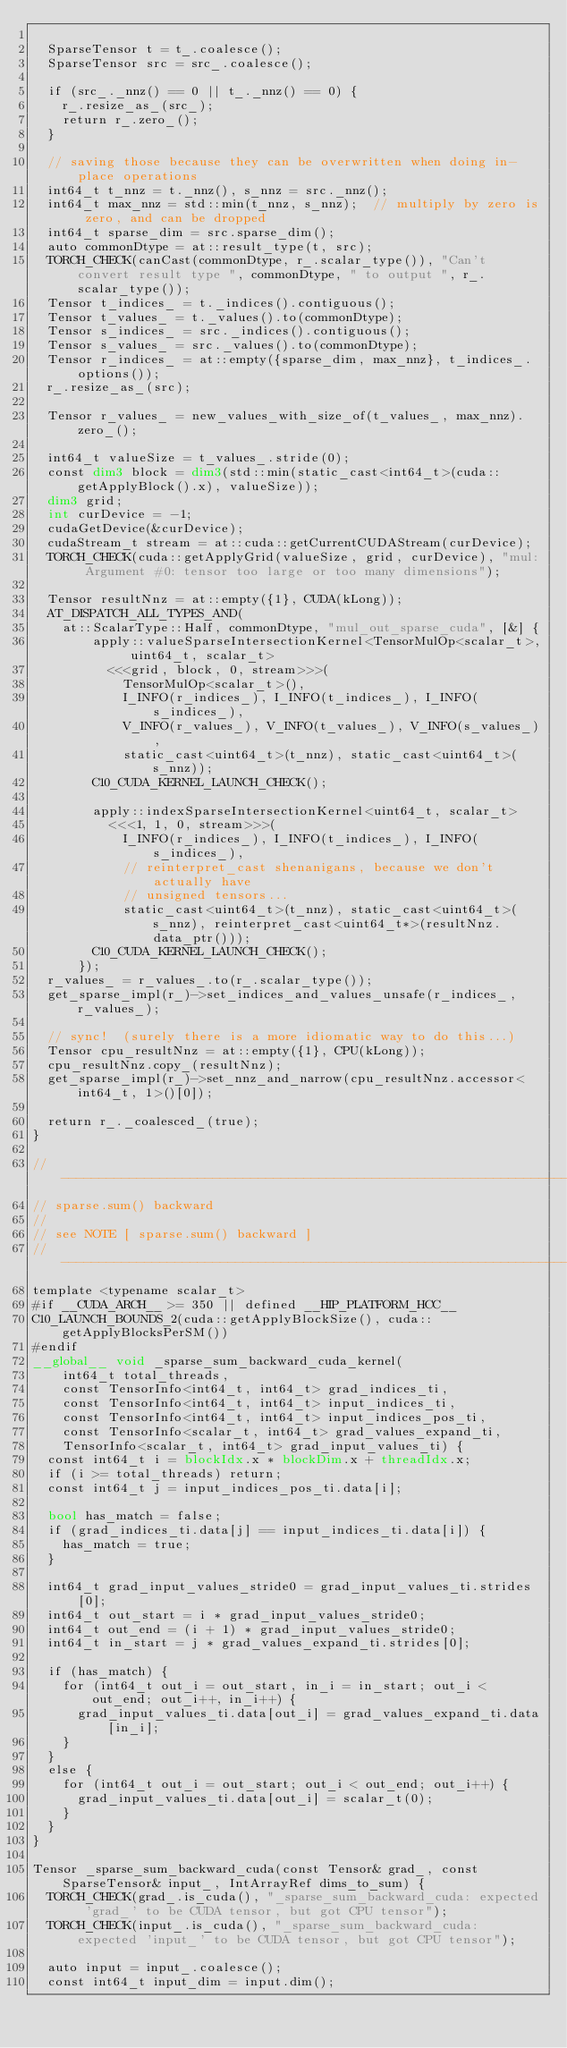Convert code to text. <code><loc_0><loc_0><loc_500><loc_500><_Cuda_>
  SparseTensor t = t_.coalesce();
  SparseTensor src = src_.coalesce();

  if (src_._nnz() == 0 || t_._nnz() == 0) {
    r_.resize_as_(src_);
    return r_.zero_();
  }

  // saving those because they can be overwritten when doing in-place operations
  int64_t t_nnz = t._nnz(), s_nnz = src._nnz();
  int64_t max_nnz = std::min(t_nnz, s_nnz);  // multiply by zero is zero, and can be dropped
  int64_t sparse_dim = src.sparse_dim();
  auto commonDtype = at::result_type(t, src);
  TORCH_CHECK(canCast(commonDtype, r_.scalar_type()), "Can't convert result type ", commonDtype, " to output ", r_.scalar_type());
  Tensor t_indices_ = t._indices().contiguous();
  Tensor t_values_ = t._values().to(commonDtype);
  Tensor s_indices_ = src._indices().contiguous();
  Tensor s_values_ = src._values().to(commonDtype);
  Tensor r_indices_ = at::empty({sparse_dim, max_nnz}, t_indices_.options());
  r_.resize_as_(src);

  Tensor r_values_ = new_values_with_size_of(t_values_, max_nnz).zero_();

  int64_t valueSize = t_values_.stride(0);
  const dim3 block = dim3(std::min(static_cast<int64_t>(cuda::getApplyBlock().x), valueSize));
  dim3 grid;
  int curDevice = -1;
  cudaGetDevice(&curDevice);
  cudaStream_t stream = at::cuda::getCurrentCUDAStream(curDevice);
  TORCH_CHECK(cuda::getApplyGrid(valueSize, grid, curDevice), "mul: Argument #0: tensor too large or too many dimensions");

  Tensor resultNnz = at::empty({1}, CUDA(kLong));
  AT_DISPATCH_ALL_TYPES_AND(
    at::ScalarType::Half, commonDtype, "mul_out_sparse_cuda", [&] {
        apply::valueSparseIntersectionKernel<TensorMulOp<scalar_t>, uint64_t, scalar_t>
          <<<grid, block, 0, stream>>>(
            TensorMulOp<scalar_t>(),
            I_INFO(r_indices_), I_INFO(t_indices_), I_INFO(s_indices_),
            V_INFO(r_values_), V_INFO(t_values_), V_INFO(s_values_),
            static_cast<uint64_t>(t_nnz), static_cast<uint64_t>(s_nnz));
        C10_CUDA_KERNEL_LAUNCH_CHECK();

        apply::indexSparseIntersectionKernel<uint64_t, scalar_t>
          <<<1, 1, 0, stream>>>(
            I_INFO(r_indices_), I_INFO(t_indices_), I_INFO(s_indices_),
            // reinterpret_cast shenanigans, because we don't actually have
            // unsigned tensors...
            static_cast<uint64_t>(t_nnz), static_cast<uint64_t>(s_nnz), reinterpret_cast<uint64_t*>(resultNnz.data_ptr()));
        C10_CUDA_KERNEL_LAUNCH_CHECK();
      });
  r_values_ = r_values_.to(r_.scalar_type());
  get_sparse_impl(r_)->set_indices_and_values_unsafe(r_indices_, r_values_);

  // sync!  (surely there is a more idiomatic way to do this...)
  Tensor cpu_resultNnz = at::empty({1}, CPU(kLong));
  cpu_resultNnz.copy_(resultNnz);
  get_sparse_impl(r_)->set_nnz_and_narrow(cpu_resultNnz.accessor<int64_t, 1>()[0]);

  return r_._coalesced_(true);
}

// --------------------------------------------------------------------
// sparse.sum() backward
//
// see NOTE [ sparse.sum() backward ]
// --------------------------------------------------------------------
template <typename scalar_t>
#if __CUDA_ARCH__ >= 350 || defined __HIP_PLATFORM_HCC__
C10_LAUNCH_BOUNDS_2(cuda::getApplyBlockSize(), cuda::getApplyBlocksPerSM())
#endif
__global__ void _sparse_sum_backward_cuda_kernel(
    int64_t total_threads,
    const TensorInfo<int64_t, int64_t> grad_indices_ti,
    const TensorInfo<int64_t, int64_t> input_indices_ti,
    const TensorInfo<int64_t, int64_t> input_indices_pos_ti,
    const TensorInfo<scalar_t, int64_t> grad_values_expand_ti,
    TensorInfo<scalar_t, int64_t> grad_input_values_ti) {
  const int64_t i = blockIdx.x * blockDim.x + threadIdx.x;
  if (i >= total_threads) return;
  const int64_t j = input_indices_pos_ti.data[i];

  bool has_match = false;
  if (grad_indices_ti.data[j] == input_indices_ti.data[i]) {
    has_match = true;
  }

  int64_t grad_input_values_stride0 = grad_input_values_ti.strides[0];
  int64_t out_start = i * grad_input_values_stride0;
  int64_t out_end = (i + 1) * grad_input_values_stride0;
  int64_t in_start = j * grad_values_expand_ti.strides[0];

  if (has_match) {
    for (int64_t out_i = out_start, in_i = in_start; out_i < out_end; out_i++, in_i++) {
      grad_input_values_ti.data[out_i] = grad_values_expand_ti.data[in_i];
    }
  }
  else {
    for (int64_t out_i = out_start; out_i < out_end; out_i++) {
      grad_input_values_ti.data[out_i] = scalar_t(0);
    }
  }
}

Tensor _sparse_sum_backward_cuda(const Tensor& grad_, const SparseTensor& input_, IntArrayRef dims_to_sum) {
  TORCH_CHECK(grad_.is_cuda(), "_sparse_sum_backward_cuda: expected 'grad_' to be CUDA tensor, but got CPU tensor");
  TORCH_CHECK(input_.is_cuda(), "_sparse_sum_backward_cuda: expected 'input_' to be CUDA tensor, but got CPU tensor");

  auto input = input_.coalesce();
  const int64_t input_dim = input.dim();</code> 